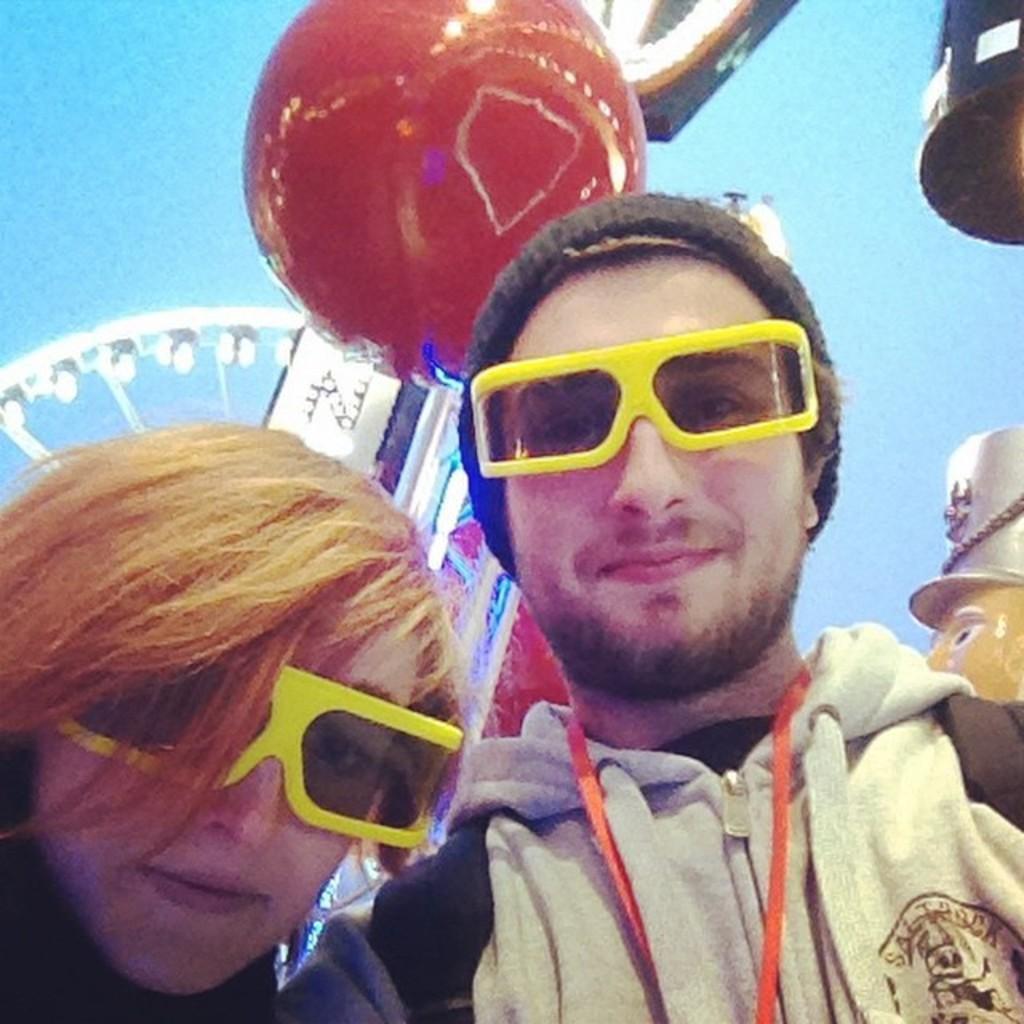Describe this image in one or two sentences. In the center of the image we can see two persons are wearing glasses. And the right side person is wearing a hat and he is smiling. In the background, we can see the sky, one balloon and a few other objects. 